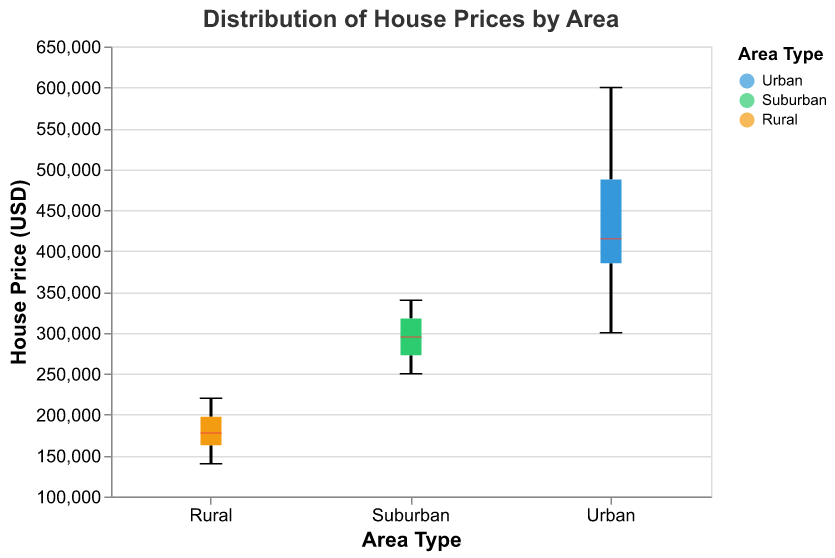What is the median house price in urban areas? The median house price in urban areas is indicated by the thick red line in the Urban box plot.
Answer: 420000 What is the minimum house price in suburban areas? The minimum house price in suburban areas is represented by the bottom whisker of the Suburban box plot.
Answer: 250000 How do the price ranges of rural areas compare to those of suburban areas? The price range in rural areas is from the minimum 140000 to the maximum 220000, while the price range in suburban areas is from the minimum 250000 to the maximum 340000.
Answer: Rural: 140000-220000, Suburban: 250000-340000 What is the interquartile range (IQR) of house prices in suburban areas? The IQR is the difference between the third quartile (Q3) and the first quartile (Q1). For Suburban, Q3 is at the top of the box plot and Q1 is at the bottom of the box.
Answer: 70,000 Which area has the highest maximum house price? By comparing the top whiskers of the Urban, Suburban, and Rural box plots, the Urban area has the highest maximum house price.
Answer: Urban What is the median house price difference between urban and rural areas? The median price for Urban is 420000 and for Rural is 175000, so the difference is 420000 - 175000.
Answer: 245000 What is the price difference between the maximum and minimum house prices in urban areas? The maximum house price in Urban areas is 600000 and the minimum is 300000. Thus, the difference is 600000 - 300000.
Answer: 300000 Which area has the more concentrated distribution of house prices, suburban or rural? The concentration of house prices is shown by the length of the box. A shorter box indicates a more concentrated distribution. Comparing the box lengths, the Rural area has a shorter box, indicating a more concentrated distribution.
Answer: Rural What is the range of house prices for the middle 50% in urban areas? The range of the middle 50% (IQR) is from the first quartile (Q1) to the third quartile (Q3) within the Urban box plot.
Answer: 380000 - 500000 Which area generally has the lowest house prices? By comparing the general height of the box plots, the Rural area has generally lower house prices than the Urban and Suburban areas.
Answer: Rural 